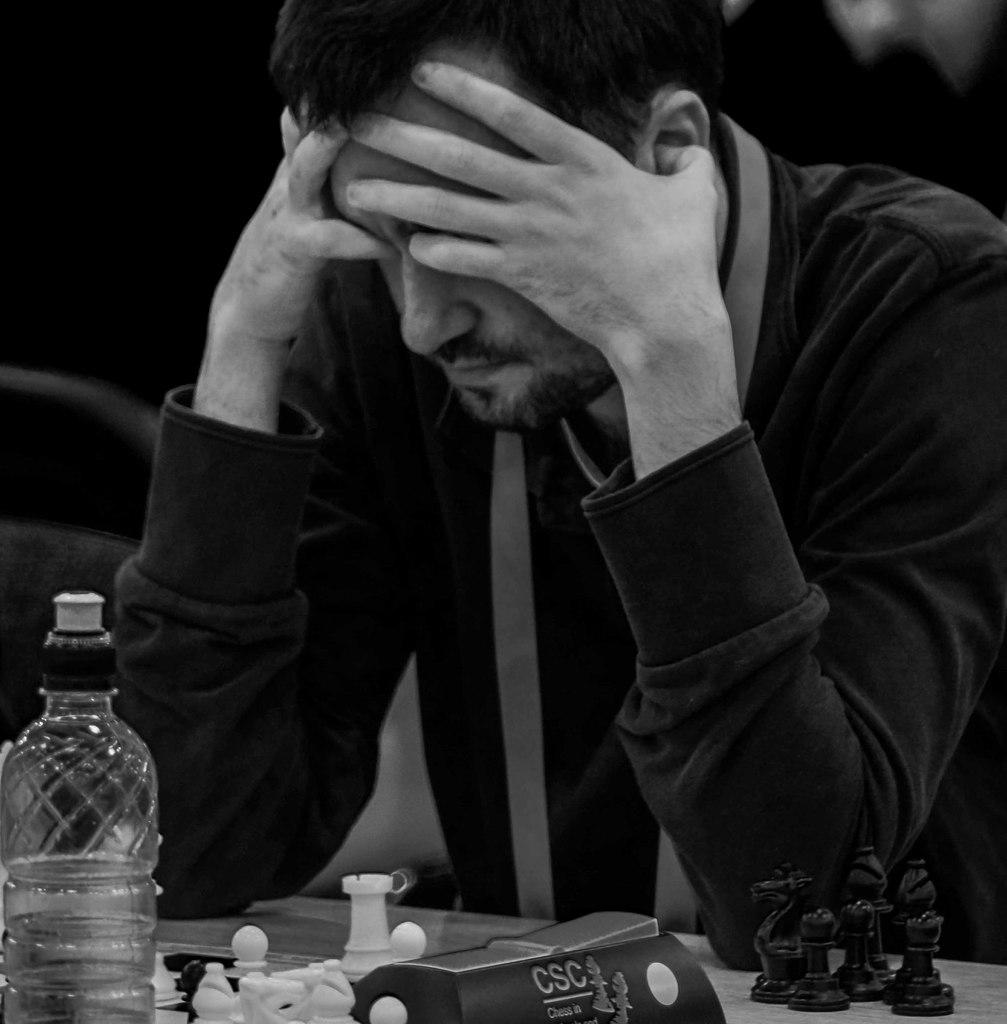Who or what is the main subject in the image? There is a person in the image. What is the person wearing? The person is wearing a black shirt. What object can be seen on the table in front of the person? There is a bottle on the table in front of the person. What type of plantation is visible in the background of the image? There is no plantation visible in the image; it only features a person, a black shirt, and a bottle on a table. 